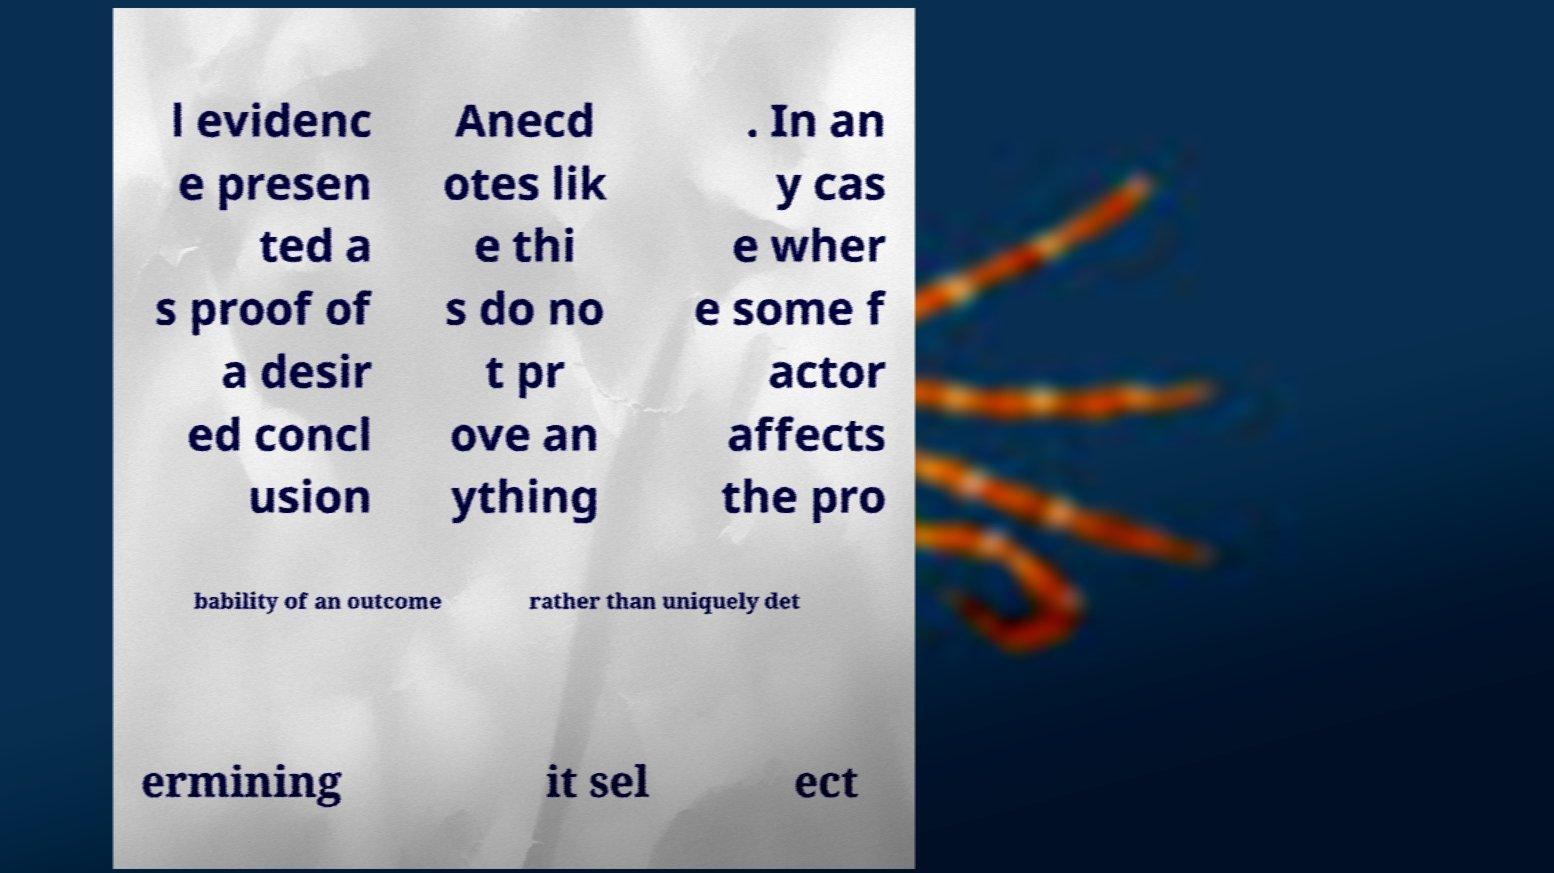There's text embedded in this image that I need extracted. Can you transcribe it verbatim? l evidenc e presen ted a s proof of a desir ed concl usion Anecd otes lik e thi s do no t pr ove an ything . In an y cas e wher e some f actor affects the pro bability of an outcome rather than uniquely det ermining it sel ect 